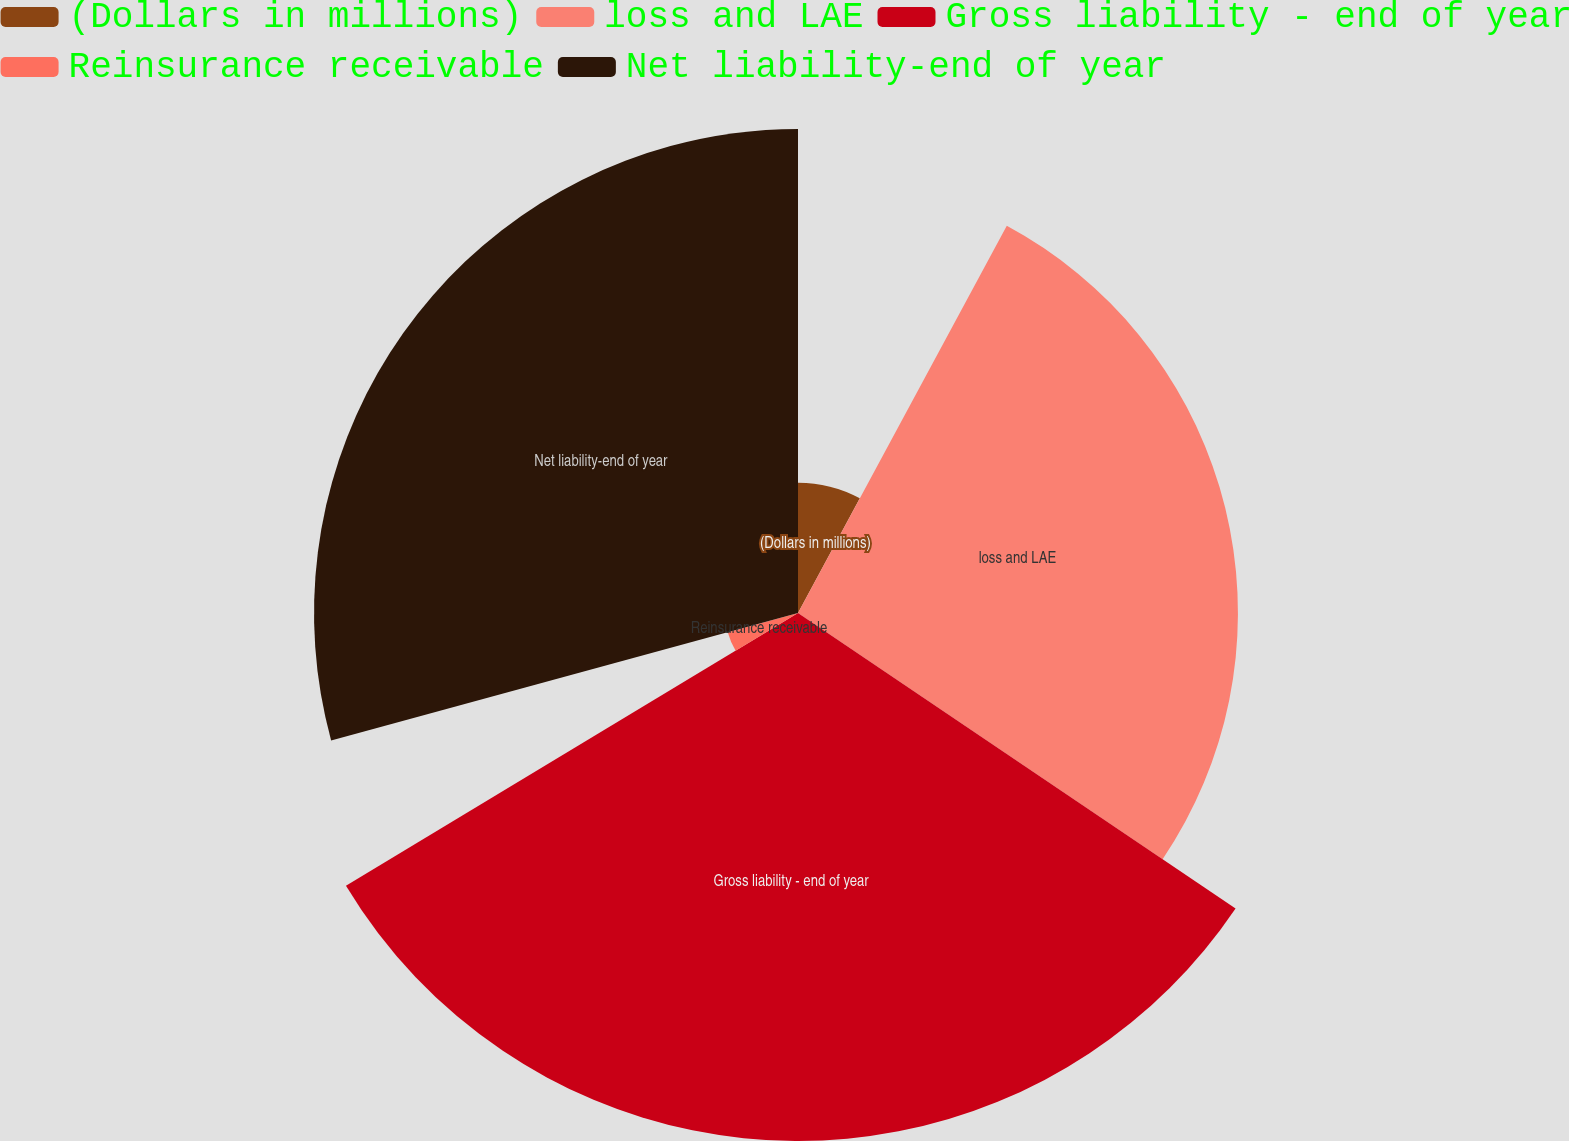<chart> <loc_0><loc_0><loc_500><loc_500><pie_chart><fcel>(Dollars in millions)<fcel>loss and LAE<fcel>Gross liability - end of year<fcel>Reinsurance receivable<fcel>Net liability-end of year<nl><fcel>7.87%<fcel>26.58%<fcel>31.9%<fcel>4.4%<fcel>29.24%<nl></chart> 